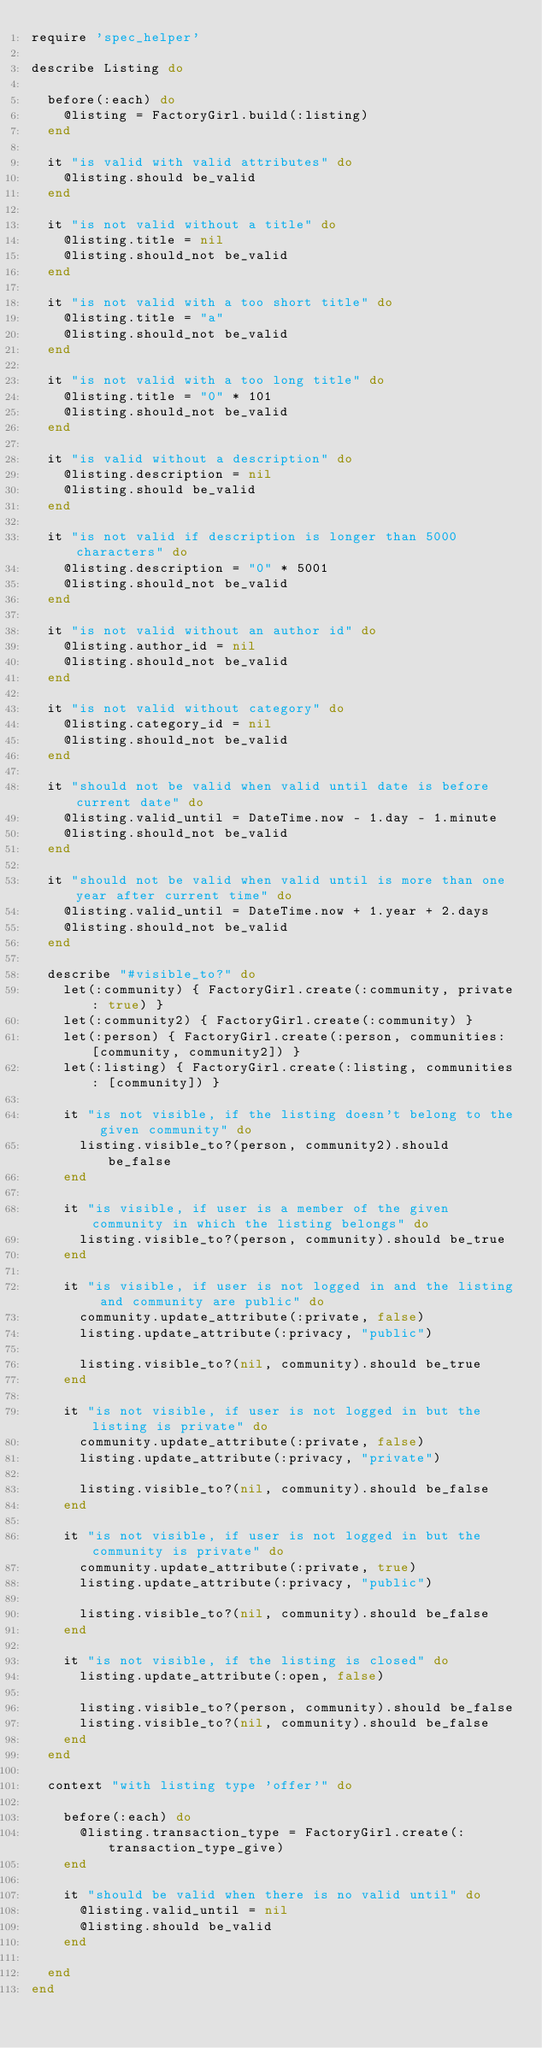Convert code to text. <code><loc_0><loc_0><loc_500><loc_500><_Ruby_>require 'spec_helper'

describe Listing do

  before(:each) do
    @listing = FactoryGirl.build(:listing)
  end

  it "is valid with valid attributes" do
    @listing.should be_valid
  end

  it "is not valid without a title" do
    @listing.title = nil
    @listing.should_not be_valid
  end

  it "is not valid with a too short title" do
    @listing.title = "a"
    @listing.should_not be_valid
  end

  it "is not valid with a too long title" do
    @listing.title = "0" * 101
    @listing.should_not be_valid
  end

  it "is valid without a description" do
    @listing.description = nil
    @listing.should be_valid
  end

  it "is not valid if description is longer than 5000 characters" do
    @listing.description = "0" * 5001
    @listing.should_not be_valid
  end

  it "is not valid without an author id" do
    @listing.author_id = nil
    @listing.should_not be_valid
  end

  it "is not valid without category" do
    @listing.category_id = nil
    @listing.should_not be_valid
  end

  it "should not be valid when valid until date is before current date" do
    @listing.valid_until = DateTime.now - 1.day - 1.minute
    @listing.should_not be_valid
  end

  it "should not be valid when valid until is more than one year after current time" do
    @listing.valid_until = DateTime.now + 1.year + 2.days
    @listing.should_not be_valid
  end

  describe "#visible_to?" do
    let(:community) { FactoryGirl.create(:community, private: true) }
    let(:community2) { FactoryGirl.create(:community) }
    let(:person) { FactoryGirl.create(:person, communities: [community, community2]) }
    let(:listing) { FactoryGirl.create(:listing, communities: [community]) }

    it "is not visible, if the listing doesn't belong to the given community" do
      listing.visible_to?(person, community2).should be_false
    end

    it "is visible, if user is a member of the given community in which the listing belongs" do
      listing.visible_to?(person, community).should be_true
    end

    it "is visible, if user is not logged in and the listing and community are public" do
      community.update_attribute(:private, false)
      listing.update_attribute(:privacy, "public")

      listing.visible_to?(nil, community).should be_true
    end

    it "is not visible, if user is not logged in but the listing is private" do
      community.update_attribute(:private, false)
      listing.update_attribute(:privacy, "private")

      listing.visible_to?(nil, community).should be_false
    end

    it "is not visible, if user is not logged in but the community is private" do
      community.update_attribute(:private, true)
      listing.update_attribute(:privacy, "public")

      listing.visible_to?(nil, community).should be_false
    end

    it "is not visible, if the listing is closed" do
      listing.update_attribute(:open, false)

      listing.visible_to?(person, community).should be_false
      listing.visible_to?(nil, community).should be_false
    end
  end

  context "with listing type 'offer'" do

    before(:each) do
      @listing.transaction_type = FactoryGirl.create(:transaction_type_give)
    end

    it "should be valid when there is no valid until" do
      @listing.valid_until = nil
      @listing.should be_valid
    end

  end
end
</code> 